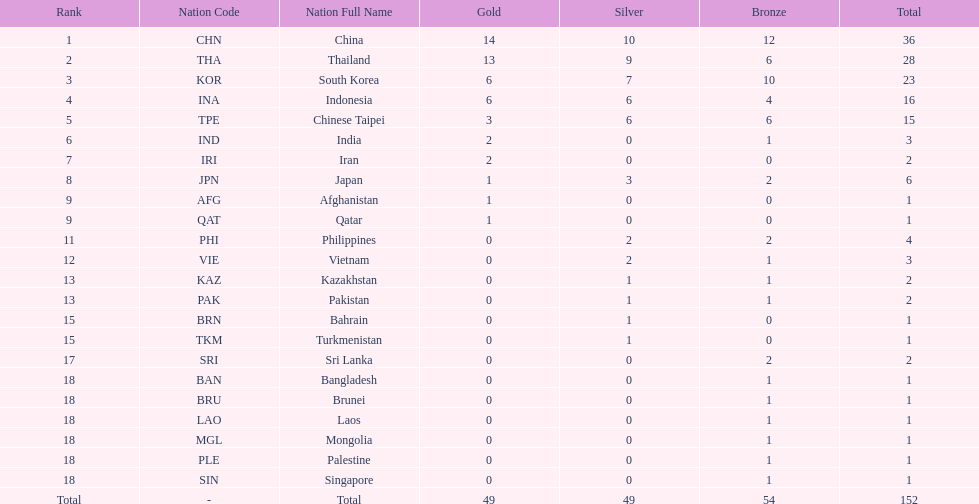What is the total number of nations that participated in the beach games of 2012? 23. 